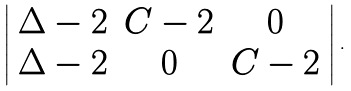Convert formula to latex. <formula><loc_0><loc_0><loc_500><loc_500>\left | \begin{array} { c c c } \Delta - 2 & C - 2 & 0 \\ \Delta - 2 & 0 & C - 2 \\ \end{array} \right | \, .</formula> 